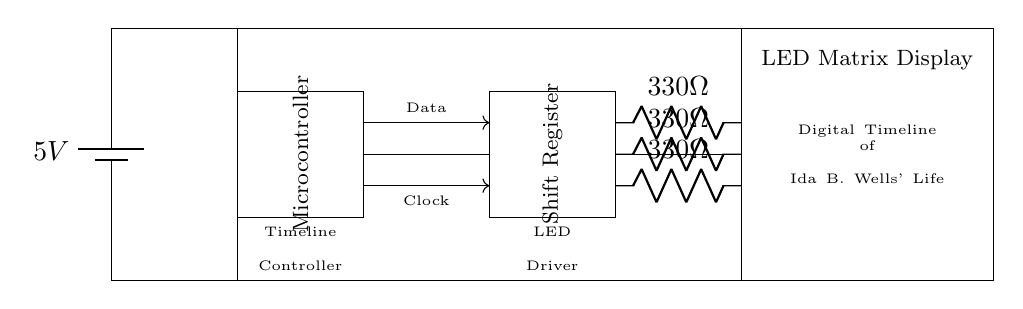What is the power supply voltage? The power supply voltage is indicated next to the battery symbol in the diagram. It states 5V, which is the voltage provided to the circuit.
Answer: 5V What is the function of the shift register? The shift register is positioned in the circuit and is labeled as such. Its main function is to receive data from the microcontroller and manage the timing for driving the LED matrix display.
Answer: Data management How many resistors are there in the circuit? The diagram shows three resistors labeled with the same resistance value. Counting them gives us a total of three resistors in the circuit.
Answer: Three What is the resistance value for each resistor? Each resistor in the circuit is labeled with a resistance value of 330 ohms, which is clearly marked next to each resistor symbol.
Answer: 330 ohms What is the purpose of the LED matrix display? The LED matrix display is labeled in the diagram and serves to visually output the digital timeline of Ida B. Wells' life, making it the main component for display purposes.
Answer: Visual output How does the microcontroller communicate with the shift register? The microcontroller sends data and clock signals to the shift register as indicated by the arrows and labels in the connections; one line is labeled "Data" and the other "Clock," showing their respective roles.
Answer: Data and clock signals 